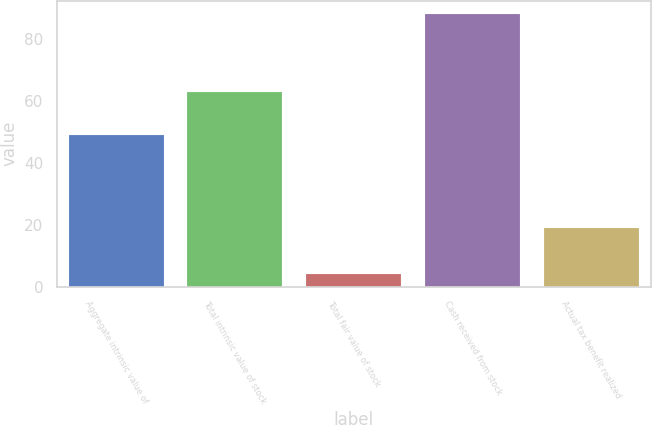Convert chart to OTSL. <chart><loc_0><loc_0><loc_500><loc_500><bar_chart><fcel>Aggregate intrinsic value of<fcel>Total intrinsic value of stock<fcel>Total fair value of stock<fcel>Cash received from stock<fcel>Actual tax benefit realized<nl><fcel>49<fcel>63<fcel>4<fcel>88<fcel>19<nl></chart> 